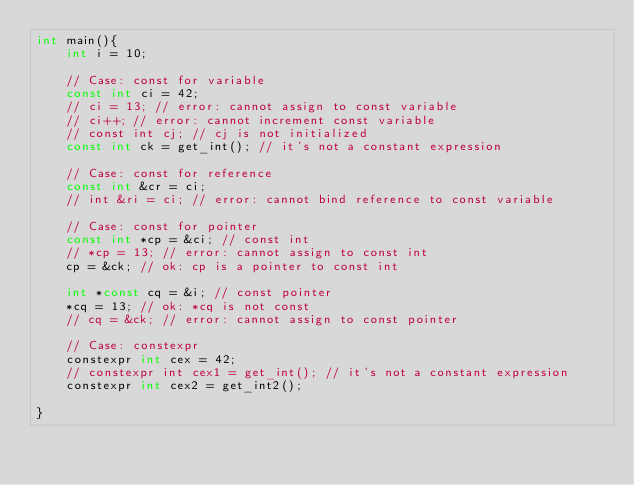<code> <loc_0><loc_0><loc_500><loc_500><_C++_>int main(){
    int i = 10;

    // Case: const for variable
    const int ci = 42;
    // ci = 13; // error: cannot assign to const variable
    // ci++; // error: cannot increment const variable
    // const int cj; // cj is not initialized
    const int ck = get_int(); // it's not a constant expression

    // Case: const for reference
    const int &cr = ci; 
    // int &ri = ci; // error: cannot bind reference to const variable

    // Case: const for pointer
    const int *cp = &ci; // const int
    // *cp = 13; // error: cannot assign to const int
    cp = &ck; // ok: cp is a pointer to const int

    int *const cq = &i; // const pointer
    *cq = 13; // ok: *cq is not const
    // cq = &ck; // error: cannot assign to const pointer

    // Case: constexpr
    constexpr int cex = 42;
    // constexpr int cex1 = get_int(); // it's not a constant expression
    constexpr int cex2 = get_int2();

}</code> 